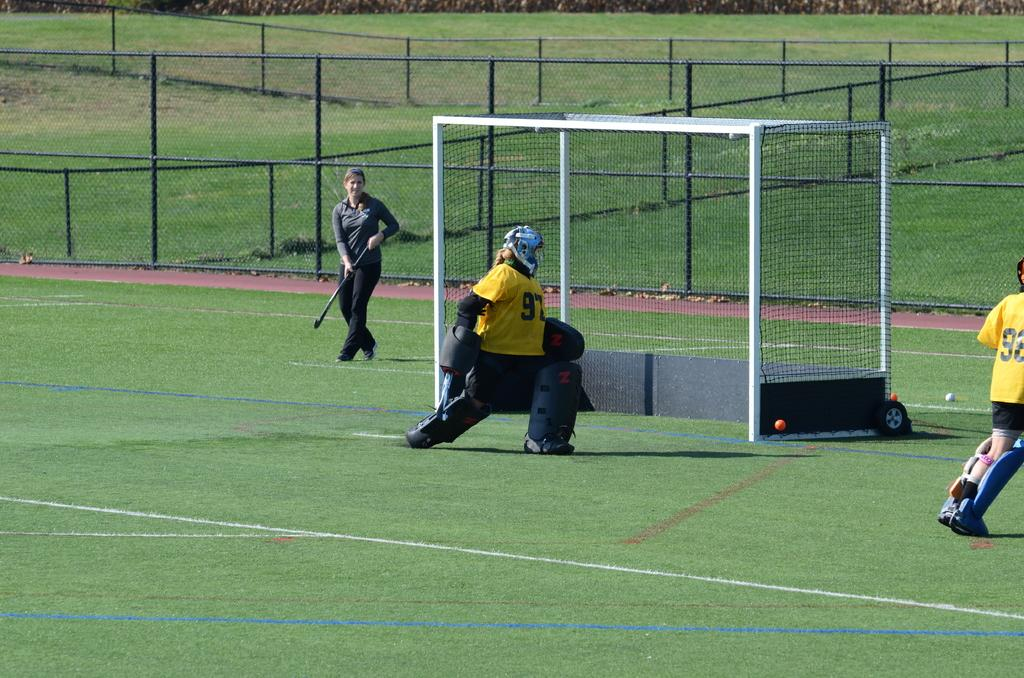Provide a one-sentence caption for the provided image. A goalie wearing number 97 protects the goal. 